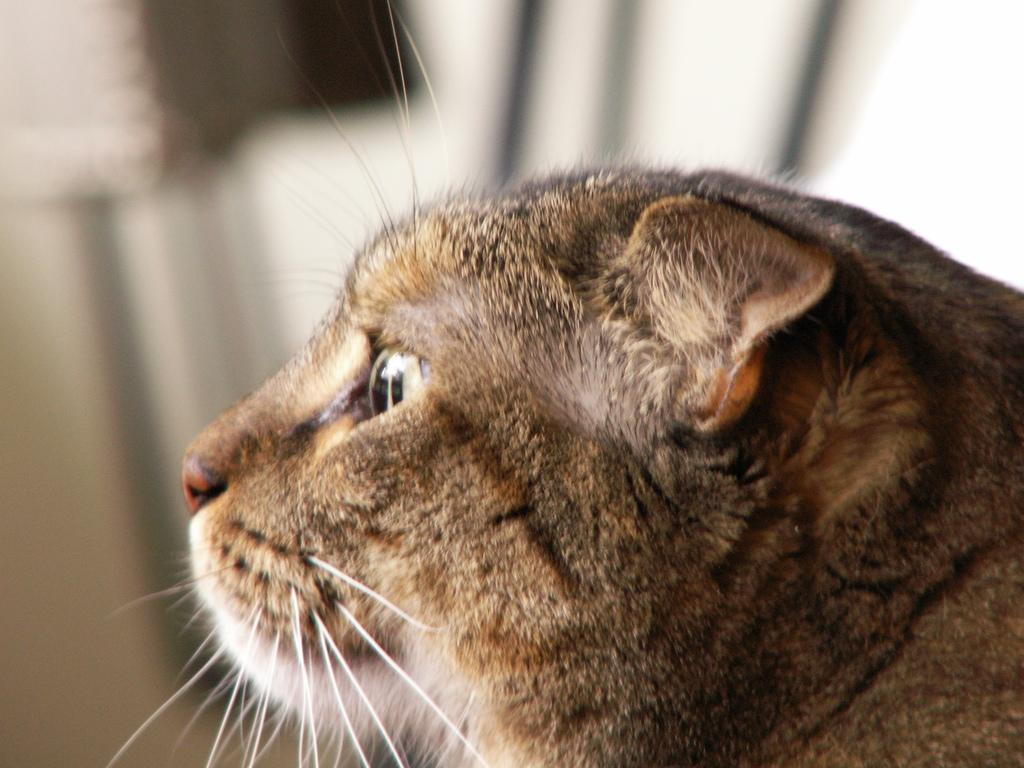What type of animal is in the image? The animal in the image has brown and black color. Can you describe the color pattern of the animal? The animal has brown and black color. What can be observed about the background of the image? The background of the image is blurred. What type of suggestion is being made by the police in the image? There is no police or suggestion present in the image; it features an animal with brown and black color against a blurred background. 